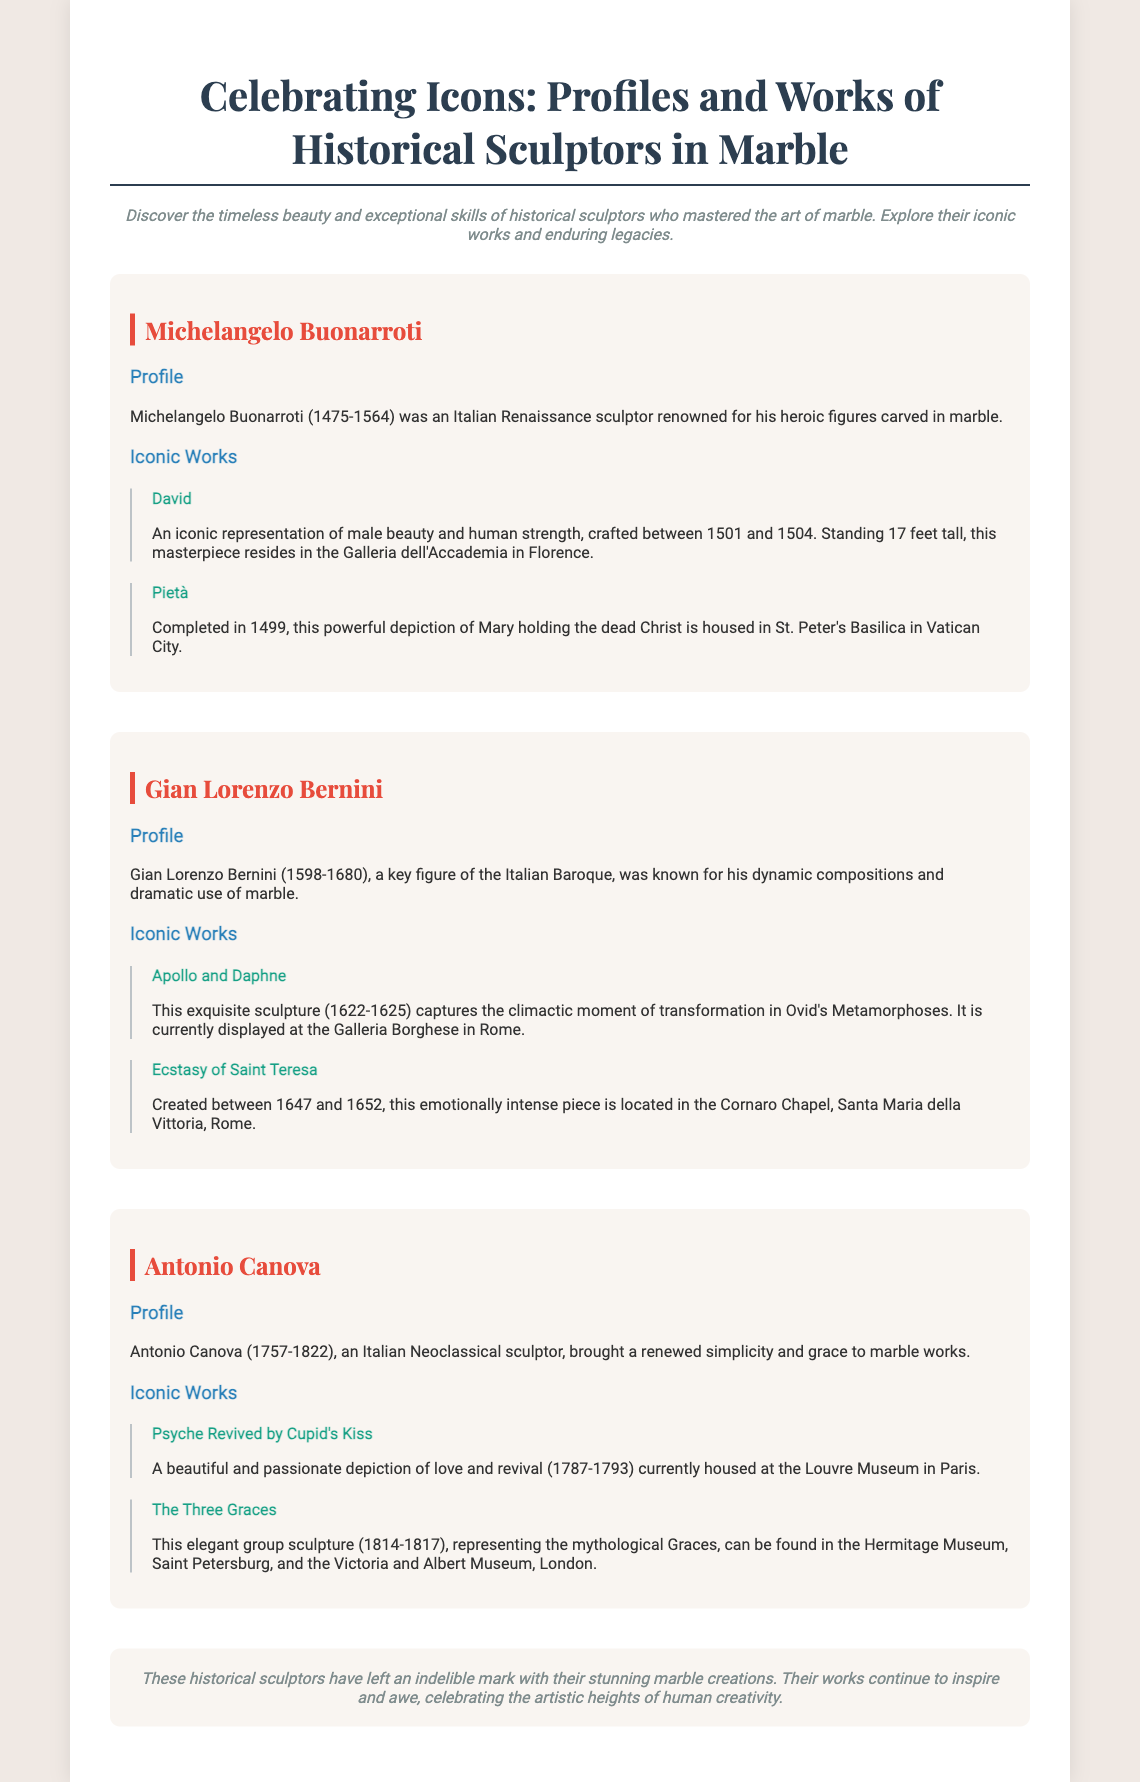What year was Michelangelo born? Michelangelo Buonarroti was born in 1475, as stated in his profile.
Answer: 1475 What is the height of the statue David? The height of the statue David is mentioned as 17 feet tall in the description of the work.
Answer: 17 feet Which museum houses the statue Pietà? The document specifies that the Pietà is housed in St. Peter's Basilica in Vatican City.
Answer: St. Peter's Basilica Who created Apollo and Daphne? The document identifies Gian Lorenzo Bernini as the creator of Apollo and Daphne, as stated in the profile section.
Answer: Gian Lorenzo Bernini How many iconic works are listed for Antonio Canova? There are two iconic works listed for Antonio Canova in the document.
Answer: Two What is the artistic style associated with Gian Lorenzo Bernini? The document defines Gian Lorenzo Bernini as a key figure of the Italian Baroque.
Answer: Italian Baroque What does the conclusion emphasize about historical sculptors? The conclusion highlights that historical sculptors have left an indelible mark with their stunning marble creations.
Answer: Indelible mark Where can The Three Graces be found? The document mentions that The Three Graces can be found in the Hermitage Museum, Saint Petersburg, and the Victoria and Albert Museum, London.
Answer: Hermitage Museum, Saint Petersburg and Victoria and Albert Museum, London 